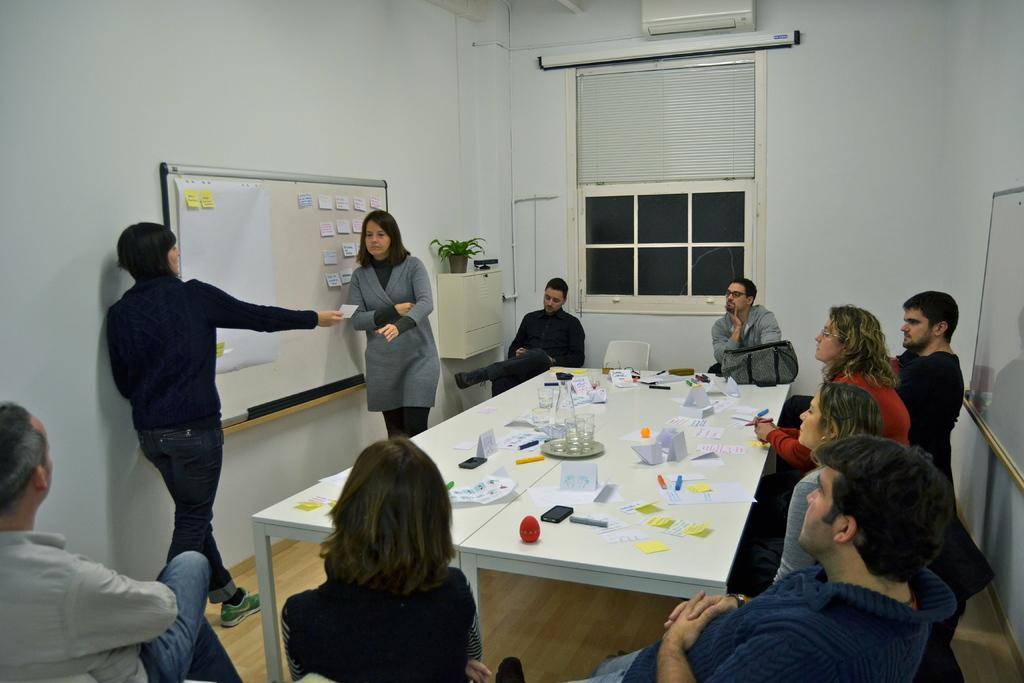Please provide a concise description of this image. This is a picture taken in a room, there are a group of people sitting on a chair in front of the people there is a table on the table there is a mobile, paper, plate, glass, pen and a bag and there are two other people are standing on the floor. Background of this people is a white board and a wall. On the right side of this people is a glass window. 